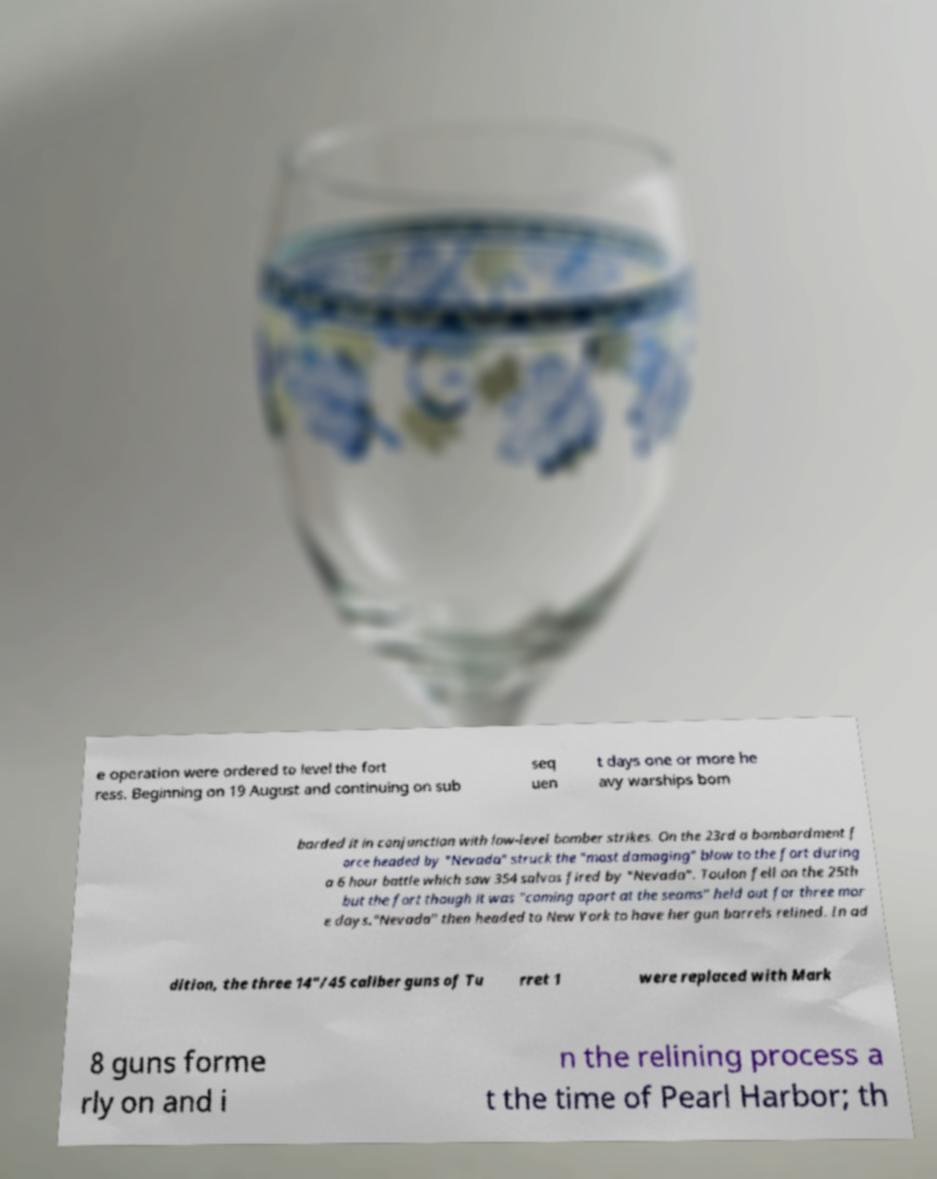There's text embedded in this image that I need extracted. Can you transcribe it verbatim? e operation were ordered to level the fort ress. Beginning on 19 August and continuing on sub seq uen t days one or more he avy warships bom barded it in conjunction with low-level bomber strikes. On the 23rd a bombardment f orce headed by "Nevada" struck the "most damaging" blow to the fort during a 6 hour battle which saw 354 salvos fired by "Nevada". Toulon fell on the 25th but the fort though it was "coming apart at the seams" held out for three mor e days."Nevada" then headed to New York to have her gun barrels relined. In ad dition, the three 14"/45 caliber guns of Tu rret 1 were replaced with Mark 8 guns forme rly on and i n the relining process a t the time of Pearl Harbor; th 